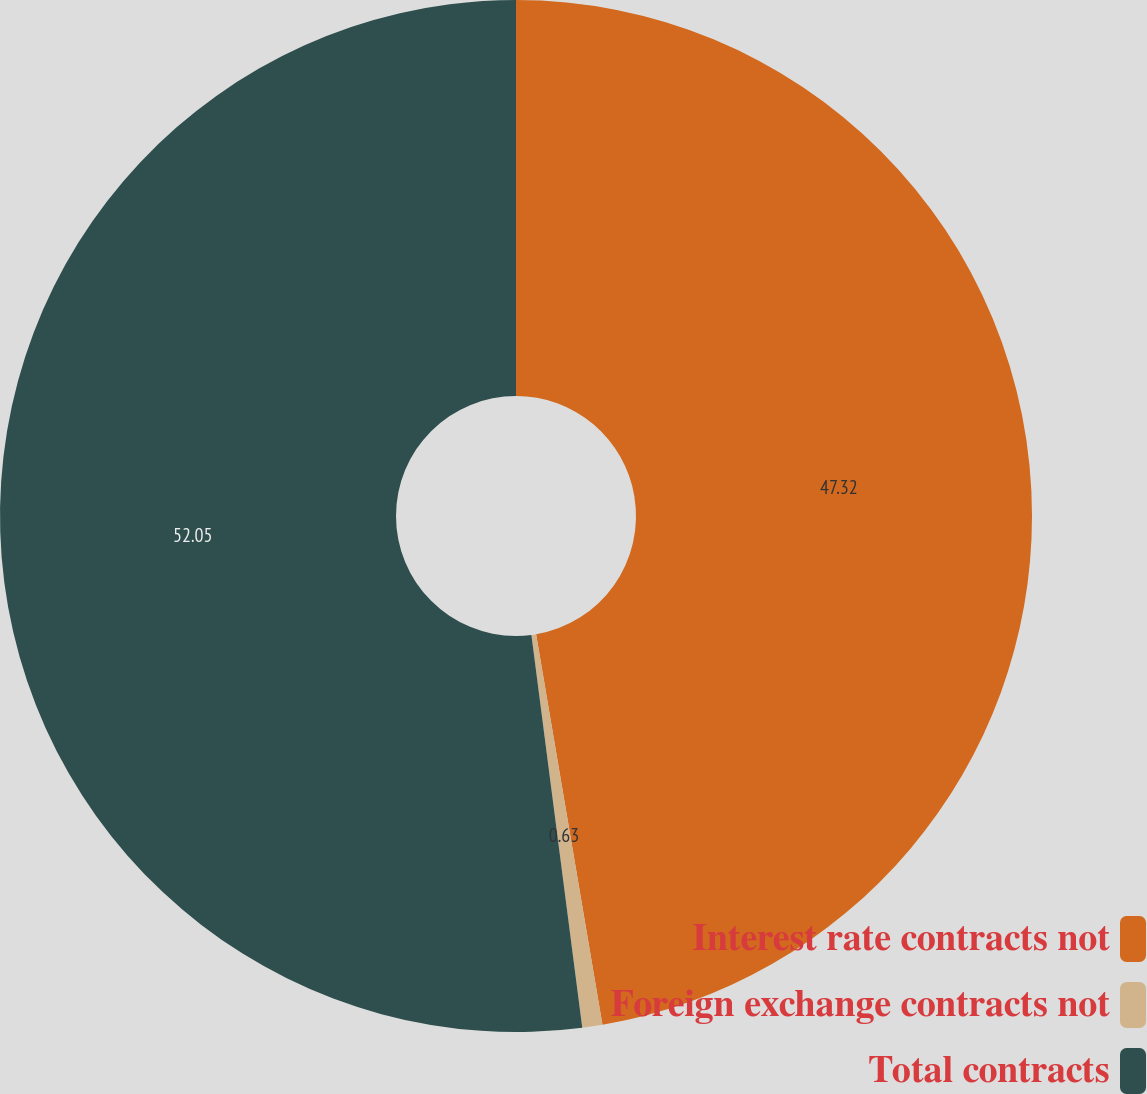Convert chart. <chart><loc_0><loc_0><loc_500><loc_500><pie_chart><fcel>Interest rate contracts not<fcel>Foreign exchange contracts not<fcel>Total contracts<nl><fcel>47.32%<fcel>0.63%<fcel>52.05%<nl></chart> 